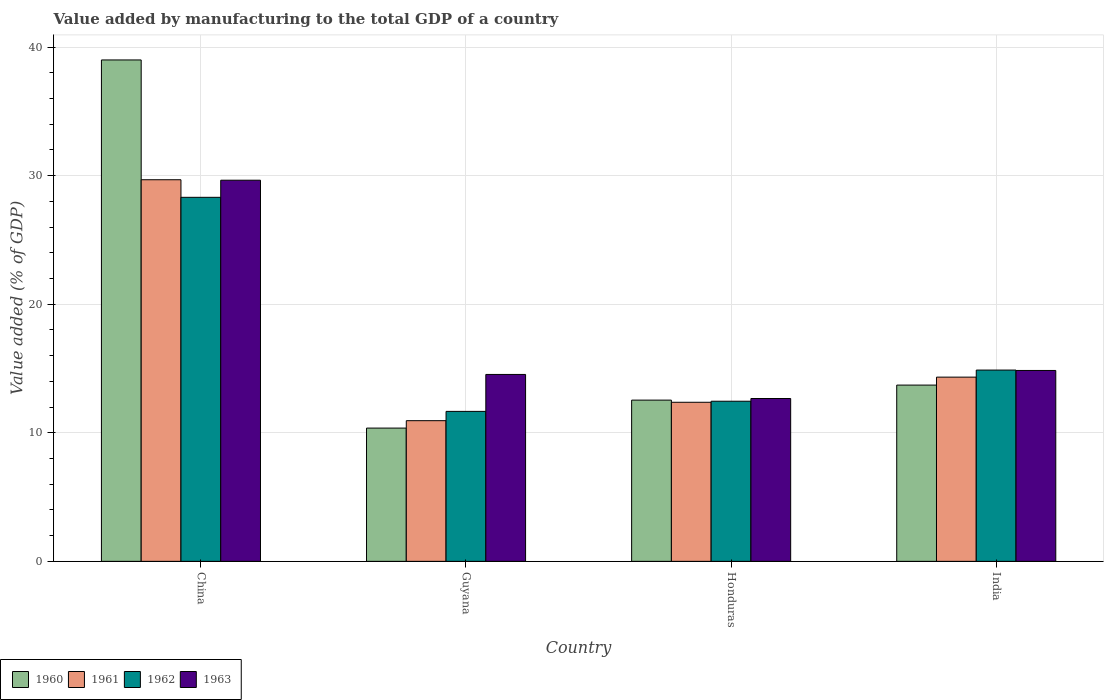How many different coloured bars are there?
Your response must be concise. 4. How many groups of bars are there?
Offer a very short reply. 4. Are the number of bars on each tick of the X-axis equal?
Your answer should be compact. Yes. How many bars are there on the 2nd tick from the left?
Provide a succinct answer. 4. What is the label of the 2nd group of bars from the left?
Your response must be concise. Guyana. What is the value added by manufacturing to the total GDP in 1962 in China?
Provide a succinct answer. 28.31. Across all countries, what is the maximum value added by manufacturing to the total GDP in 1961?
Provide a succinct answer. 29.68. Across all countries, what is the minimum value added by manufacturing to the total GDP in 1961?
Your response must be concise. 10.94. In which country was the value added by manufacturing to the total GDP in 1963 minimum?
Provide a short and direct response. Honduras. What is the total value added by manufacturing to the total GDP in 1963 in the graph?
Keep it short and to the point. 71.69. What is the difference between the value added by manufacturing to the total GDP in 1960 in Guyana and that in India?
Your response must be concise. -3.34. What is the difference between the value added by manufacturing to the total GDP in 1961 in Guyana and the value added by manufacturing to the total GDP in 1960 in India?
Give a very brief answer. -2.77. What is the average value added by manufacturing to the total GDP in 1960 per country?
Your response must be concise. 18.9. What is the difference between the value added by manufacturing to the total GDP of/in 1962 and value added by manufacturing to the total GDP of/in 1961 in China?
Offer a terse response. -1.37. In how many countries, is the value added by manufacturing to the total GDP in 1961 greater than 14 %?
Your answer should be very brief. 2. What is the ratio of the value added by manufacturing to the total GDP in 1961 in Guyana to that in Honduras?
Make the answer very short. 0.88. Is the difference between the value added by manufacturing to the total GDP in 1962 in China and India greater than the difference between the value added by manufacturing to the total GDP in 1961 in China and India?
Keep it short and to the point. No. What is the difference between the highest and the second highest value added by manufacturing to the total GDP in 1961?
Give a very brief answer. -17.31. What is the difference between the highest and the lowest value added by manufacturing to the total GDP in 1961?
Offer a very short reply. 18.74. In how many countries, is the value added by manufacturing to the total GDP in 1961 greater than the average value added by manufacturing to the total GDP in 1961 taken over all countries?
Offer a very short reply. 1. Is the sum of the value added by manufacturing to the total GDP in 1962 in China and Guyana greater than the maximum value added by manufacturing to the total GDP in 1961 across all countries?
Offer a very short reply. Yes. Is it the case that in every country, the sum of the value added by manufacturing to the total GDP in 1962 and value added by manufacturing to the total GDP in 1960 is greater than the sum of value added by manufacturing to the total GDP in 1963 and value added by manufacturing to the total GDP in 1961?
Provide a succinct answer. No. What does the 4th bar from the left in Guyana represents?
Make the answer very short. 1963. What does the 4th bar from the right in Honduras represents?
Make the answer very short. 1960. How many bars are there?
Give a very brief answer. 16. Are all the bars in the graph horizontal?
Your answer should be compact. No. Are the values on the major ticks of Y-axis written in scientific E-notation?
Your answer should be very brief. No. Does the graph contain any zero values?
Offer a very short reply. No. Does the graph contain grids?
Provide a succinct answer. Yes. Where does the legend appear in the graph?
Your answer should be compact. Bottom left. How are the legend labels stacked?
Ensure brevity in your answer.  Horizontal. What is the title of the graph?
Your answer should be compact. Value added by manufacturing to the total GDP of a country. What is the label or title of the X-axis?
Your response must be concise. Country. What is the label or title of the Y-axis?
Offer a very short reply. Value added (% of GDP). What is the Value added (% of GDP) in 1960 in China?
Your answer should be very brief. 39. What is the Value added (% of GDP) in 1961 in China?
Provide a short and direct response. 29.68. What is the Value added (% of GDP) of 1962 in China?
Give a very brief answer. 28.31. What is the Value added (% of GDP) of 1963 in China?
Keep it short and to the point. 29.64. What is the Value added (% of GDP) in 1960 in Guyana?
Keep it short and to the point. 10.37. What is the Value added (% of GDP) in 1961 in Guyana?
Give a very brief answer. 10.94. What is the Value added (% of GDP) in 1962 in Guyana?
Your answer should be very brief. 11.66. What is the Value added (% of GDP) of 1963 in Guyana?
Keep it short and to the point. 14.54. What is the Value added (% of GDP) in 1960 in Honduras?
Keep it short and to the point. 12.54. What is the Value added (% of GDP) in 1961 in Honduras?
Your answer should be very brief. 12.37. What is the Value added (% of GDP) of 1962 in Honduras?
Your answer should be very brief. 12.45. What is the Value added (% of GDP) of 1963 in Honduras?
Your answer should be compact. 12.67. What is the Value added (% of GDP) of 1960 in India?
Your response must be concise. 13.71. What is the Value added (% of GDP) in 1961 in India?
Give a very brief answer. 14.33. What is the Value added (% of GDP) of 1962 in India?
Provide a succinct answer. 14.88. What is the Value added (% of GDP) in 1963 in India?
Make the answer very short. 14.85. Across all countries, what is the maximum Value added (% of GDP) of 1960?
Provide a short and direct response. 39. Across all countries, what is the maximum Value added (% of GDP) in 1961?
Offer a terse response. 29.68. Across all countries, what is the maximum Value added (% of GDP) in 1962?
Your answer should be very brief. 28.31. Across all countries, what is the maximum Value added (% of GDP) in 1963?
Offer a very short reply. 29.64. Across all countries, what is the minimum Value added (% of GDP) in 1960?
Provide a short and direct response. 10.37. Across all countries, what is the minimum Value added (% of GDP) of 1961?
Provide a short and direct response. 10.94. Across all countries, what is the minimum Value added (% of GDP) of 1962?
Provide a short and direct response. 11.66. Across all countries, what is the minimum Value added (% of GDP) in 1963?
Offer a terse response. 12.67. What is the total Value added (% of GDP) of 1960 in the graph?
Offer a very short reply. 75.61. What is the total Value added (% of GDP) of 1961 in the graph?
Keep it short and to the point. 67.32. What is the total Value added (% of GDP) of 1962 in the graph?
Keep it short and to the point. 67.31. What is the total Value added (% of GDP) in 1963 in the graph?
Make the answer very short. 71.69. What is the difference between the Value added (% of GDP) of 1960 in China and that in Guyana?
Keep it short and to the point. 28.63. What is the difference between the Value added (% of GDP) of 1961 in China and that in Guyana?
Give a very brief answer. 18.74. What is the difference between the Value added (% of GDP) in 1962 in China and that in Guyana?
Ensure brevity in your answer.  16.65. What is the difference between the Value added (% of GDP) of 1963 in China and that in Guyana?
Your answer should be compact. 15.11. What is the difference between the Value added (% of GDP) in 1960 in China and that in Honduras?
Offer a terse response. 26.46. What is the difference between the Value added (% of GDP) in 1961 in China and that in Honduras?
Offer a very short reply. 17.31. What is the difference between the Value added (% of GDP) in 1962 in China and that in Honduras?
Your answer should be very brief. 15.86. What is the difference between the Value added (% of GDP) in 1963 in China and that in Honduras?
Offer a very short reply. 16.98. What is the difference between the Value added (% of GDP) in 1960 in China and that in India?
Offer a very short reply. 25.29. What is the difference between the Value added (% of GDP) of 1961 in China and that in India?
Keep it short and to the point. 15.35. What is the difference between the Value added (% of GDP) in 1962 in China and that in India?
Ensure brevity in your answer.  13.43. What is the difference between the Value added (% of GDP) in 1963 in China and that in India?
Provide a short and direct response. 14.8. What is the difference between the Value added (% of GDP) in 1960 in Guyana and that in Honduras?
Give a very brief answer. -2.18. What is the difference between the Value added (% of GDP) of 1961 in Guyana and that in Honduras?
Keep it short and to the point. -1.43. What is the difference between the Value added (% of GDP) of 1962 in Guyana and that in Honduras?
Provide a succinct answer. -0.79. What is the difference between the Value added (% of GDP) in 1963 in Guyana and that in Honduras?
Provide a short and direct response. 1.87. What is the difference between the Value added (% of GDP) of 1960 in Guyana and that in India?
Make the answer very short. -3.34. What is the difference between the Value added (% of GDP) in 1961 in Guyana and that in India?
Offer a terse response. -3.39. What is the difference between the Value added (% of GDP) of 1962 in Guyana and that in India?
Give a very brief answer. -3.21. What is the difference between the Value added (% of GDP) in 1963 in Guyana and that in India?
Your answer should be very brief. -0.31. What is the difference between the Value added (% of GDP) in 1960 in Honduras and that in India?
Provide a succinct answer. -1.17. What is the difference between the Value added (% of GDP) of 1961 in Honduras and that in India?
Your answer should be very brief. -1.96. What is the difference between the Value added (% of GDP) in 1962 in Honduras and that in India?
Offer a terse response. -2.42. What is the difference between the Value added (% of GDP) of 1963 in Honduras and that in India?
Your answer should be compact. -2.18. What is the difference between the Value added (% of GDP) of 1960 in China and the Value added (% of GDP) of 1961 in Guyana?
Provide a succinct answer. 28.06. What is the difference between the Value added (% of GDP) in 1960 in China and the Value added (% of GDP) in 1962 in Guyana?
Offer a very short reply. 27.33. What is the difference between the Value added (% of GDP) of 1960 in China and the Value added (% of GDP) of 1963 in Guyana?
Ensure brevity in your answer.  24.46. What is the difference between the Value added (% of GDP) in 1961 in China and the Value added (% of GDP) in 1962 in Guyana?
Offer a very short reply. 18.02. What is the difference between the Value added (% of GDP) in 1961 in China and the Value added (% of GDP) in 1963 in Guyana?
Offer a terse response. 15.14. What is the difference between the Value added (% of GDP) of 1962 in China and the Value added (% of GDP) of 1963 in Guyana?
Your response must be concise. 13.78. What is the difference between the Value added (% of GDP) of 1960 in China and the Value added (% of GDP) of 1961 in Honduras?
Ensure brevity in your answer.  26.63. What is the difference between the Value added (% of GDP) of 1960 in China and the Value added (% of GDP) of 1962 in Honduras?
Keep it short and to the point. 26.54. What is the difference between the Value added (% of GDP) in 1960 in China and the Value added (% of GDP) in 1963 in Honduras?
Your answer should be very brief. 26.33. What is the difference between the Value added (% of GDP) in 1961 in China and the Value added (% of GDP) in 1962 in Honduras?
Ensure brevity in your answer.  17.23. What is the difference between the Value added (% of GDP) in 1961 in China and the Value added (% of GDP) in 1963 in Honduras?
Provide a short and direct response. 17.01. What is the difference between the Value added (% of GDP) in 1962 in China and the Value added (% of GDP) in 1963 in Honduras?
Give a very brief answer. 15.65. What is the difference between the Value added (% of GDP) of 1960 in China and the Value added (% of GDP) of 1961 in India?
Provide a short and direct response. 24.67. What is the difference between the Value added (% of GDP) of 1960 in China and the Value added (% of GDP) of 1962 in India?
Offer a very short reply. 24.12. What is the difference between the Value added (% of GDP) in 1960 in China and the Value added (% of GDP) in 1963 in India?
Your response must be concise. 24.15. What is the difference between the Value added (% of GDP) of 1961 in China and the Value added (% of GDP) of 1962 in India?
Make the answer very short. 14.8. What is the difference between the Value added (% of GDP) of 1961 in China and the Value added (% of GDP) of 1963 in India?
Provide a succinct answer. 14.83. What is the difference between the Value added (% of GDP) of 1962 in China and the Value added (% of GDP) of 1963 in India?
Give a very brief answer. 13.47. What is the difference between the Value added (% of GDP) of 1960 in Guyana and the Value added (% of GDP) of 1961 in Honduras?
Offer a terse response. -2.01. What is the difference between the Value added (% of GDP) in 1960 in Guyana and the Value added (% of GDP) in 1962 in Honduras?
Provide a succinct answer. -2.09. What is the difference between the Value added (% of GDP) of 1960 in Guyana and the Value added (% of GDP) of 1963 in Honduras?
Offer a terse response. -2.3. What is the difference between the Value added (% of GDP) of 1961 in Guyana and the Value added (% of GDP) of 1962 in Honduras?
Keep it short and to the point. -1.51. What is the difference between the Value added (% of GDP) of 1961 in Guyana and the Value added (% of GDP) of 1963 in Honduras?
Your answer should be very brief. -1.73. What is the difference between the Value added (% of GDP) in 1962 in Guyana and the Value added (% of GDP) in 1963 in Honduras?
Make the answer very short. -1. What is the difference between the Value added (% of GDP) in 1960 in Guyana and the Value added (% of GDP) in 1961 in India?
Ensure brevity in your answer.  -3.96. What is the difference between the Value added (% of GDP) in 1960 in Guyana and the Value added (% of GDP) in 1962 in India?
Give a very brief answer. -4.51. What is the difference between the Value added (% of GDP) in 1960 in Guyana and the Value added (% of GDP) in 1963 in India?
Give a very brief answer. -4.48. What is the difference between the Value added (% of GDP) in 1961 in Guyana and the Value added (% of GDP) in 1962 in India?
Make the answer very short. -3.94. What is the difference between the Value added (% of GDP) of 1961 in Guyana and the Value added (% of GDP) of 1963 in India?
Offer a terse response. -3.91. What is the difference between the Value added (% of GDP) in 1962 in Guyana and the Value added (% of GDP) in 1963 in India?
Make the answer very short. -3.18. What is the difference between the Value added (% of GDP) of 1960 in Honduras and the Value added (% of GDP) of 1961 in India?
Your answer should be compact. -1.79. What is the difference between the Value added (% of GDP) of 1960 in Honduras and the Value added (% of GDP) of 1962 in India?
Your answer should be compact. -2.34. What is the difference between the Value added (% of GDP) of 1960 in Honduras and the Value added (% of GDP) of 1963 in India?
Ensure brevity in your answer.  -2.31. What is the difference between the Value added (% of GDP) of 1961 in Honduras and the Value added (% of GDP) of 1962 in India?
Ensure brevity in your answer.  -2.51. What is the difference between the Value added (% of GDP) of 1961 in Honduras and the Value added (% of GDP) of 1963 in India?
Provide a succinct answer. -2.47. What is the difference between the Value added (% of GDP) of 1962 in Honduras and the Value added (% of GDP) of 1963 in India?
Ensure brevity in your answer.  -2.39. What is the average Value added (% of GDP) of 1960 per country?
Your answer should be compact. 18.9. What is the average Value added (% of GDP) of 1961 per country?
Your answer should be compact. 16.83. What is the average Value added (% of GDP) of 1962 per country?
Keep it short and to the point. 16.83. What is the average Value added (% of GDP) of 1963 per country?
Make the answer very short. 17.92. What is the difference between the Value added (% of GDP) in 1960 and Value added (% of GDP) in 1961 in China?
Your response must be concise. 9.32. What is the difference between the Value added (% of GDP) in 1960 and Value added (% of GDP) in 1962 in China?
Provide a succinct answer. 10.69. What is the difference between the Value added (% of GDP) of 1960 and Value added (% of GDP) of 1963 in China?
Give a very brief answer. 9.35. What is the difference between the Value added (% of GDP) of 1961 and Value added (% of GDP) of 1962 in China?
Your response must be concise. 1.37. What is the difference between the Value added (% of GDP) in 1961 and Value added (% of GDP) in 1963 in China?
Your response must be concise. 0.04. What is the difference between the Value added (% of GDP) of 1962 and Value added (% of GDP) of 1963 in China?
Your answer should be very brief. -1.33. What is the difference between the Value added (% of GDP) of 1960 and Value added (% of GDP) of 1961 in Guyana?
Your answer should be compact. -0.58. What is the difference between the Value added (% of GDP) of 1960 and Value added (% of GDP) of 1962 in Guyana?
Your answer should be compact. -1.3. What is the difference between the Value added (% of GDP) of 1960 and Value added (% of GDP) of 1963 in Guyana?
Provide a short and direct response. -4.17. What is the difference between the Value added (% of GDP) of 1961 and Value added (% of GDP) of 1962 in Guyana?
Give a very brief answer. -0.72. What is the difference between the Value added (% of GDP) of 1961 and Value added (% of GDP) of 1963 in Guyana?
Your response must be concise. -3.6. What is the difference between the Value added (% of GDP) in 1962 and Value added (% of GDP) in 1963 in Guyana?
Make the answer very short. -2.87. What is the difference between the Value added (% of GDP) in 1960 and Value added (% of GDP) in 1961 in Honduras?
Keep it short and to the point. 0.17. What is the difference between the Value added (% of GDP) in 1960 and Value added (% of GDP) in 1962 in Honduras?
Ensure brevity in your answer.  0.09. What is the difference between the Value added (% of GDP) in 1960 and Value added (% of GDP) in 1963 in Honduras?
Offer a very short reply. -0.13. What is the difference between the Value added (% of GDP) in 1961 and Value added (% of GDP) in 1962 in Honduras?
Offer a very short reply. -0.08. What is the difference between the Value added (% of GDP) in 1961 and Value added (% of GDP) in 1963 in Honduras?
Give a very brief answer. -0.29. What is the difference between the Value added (% of GDP) of 1962 and Value added (% of GDP) of 1963 in Honduras?
Provide a short and direct response. -0.21. What is the difference between the Value added (% of GDP) of 1960 and Value added (% of GDP) of 1961 in India?
Your response must be concise. -0.62. What is the difference between the Value added (% of GDP) in 1960 and Value added (% of GDP) in 1962 in India?
Ensure brevity in your answer.  -1.17. What is the difference between the Value added (% of GDP) in 1960 and Value added (% of GDP) in 1963 in India?
Give a very brief answer. -1.14. What is the difference between the Value added (% of GDP) of 1961 and Value added (% of GDP) of 1962 in India?
Offer a very short reply. -0.55. What is the difference between the Value added (% of GDP) in 1961 and Value added (% of GDP) in 1963 in India?
Your response must be concise. -0.52. What is the difference between the Value added (% of GDP) in 1962 and Value added (% of GDP) in 1963 in India?
Provide a short and direct response. 0.03. What is the ratio of the Value added (% of GDP) in 1960 in China to that in Guyana?
Ensure brevity in your answer.  3.76. What is the ratio of the Value added (% of GDP) of 1961 in China to that in Guyana?
Offer a terse response. 2.71. What is the ratio of the Value added (% of GDP) in 1962 in China to that in Guyana?
Provide a succinct answer. 2.43. What is the ratio of the Value added (% of GDP) in 1963 in China to that in Guyana?
Offer a terse response. 2.04. What is the ratio of the Value added (% of GDP) of 1960 in China to that in Honduras?
Offer a very short reply. 3.11. What is the ratio of the Value added (% of GDP) in 1961 in China to that in Honduras?
Ensure brevity in your answer.  2.4. What is the ratio of the Value added (% of GDP) in 1962 in China to that in Honduras?
Your answer should be very brief. 2.27. What is the ratio of the Value added (% of GDP) in 1963 in China to that in Honduras?
Your answer should be compact. 2.34. What is the ratio of the Value added (% of GDP) of 1960 in China to that in India?
Make the answer very short. 2.84. What is the ratio of the Value added (% of GDP) of 1961 in China to that in India?
Offer a very short reply. 2.07. What is the ratio of the Value added (% of GDP) of 1962 in China to that in India?
Offer a very short reply. 1.9. What is the ratio of the Value added (% of GDP) of 1963 in China to that in India?
Your response must be concise. 2. What is the ratio of the Value added (% of GDP) in 1960 in Guyana to that in Honduras?
Give a very brief answer. 0.83. What is the ratio of the Value added (% of GDP) in 1961 in Guyana to that in Honduras?
Offer a terse response. 0.88. What is the ratio of the Value added (% of GDP) in 1962 in Guyana to that in Honduras?
Your response must be concise. 0.94. What is the ratio of the Value added (% of GDP) in 1963 in Guyana to that in Honduras?
Provide a short and direct response. 1.15. What is the ratio of the Value added (% of GDP) in 1960 in Guyana to that in India?
Ensure brevity in your answer.  0.76. What is the ratio of the Value added (% of GDP) in 1961 in Guyana to that in India?
Ensure brevity in your answer.  0.76. What is the ratio of the Value added (% of GDP) of 1962 in Guyana to that in India?
Your answer should be compact. 0.78. What is the ratio of the Value added (% of GDP) in 1963 in Guyana to that in India?
Provide a succinct answer. 0.98. What is the ratio of the Value added (% of GDP) in 1960 in Honduras to that in India?
Offer a terse response. 0.91. What is the ratio of the Value added (% of GDP) in 1961 in Honduras to that in India?
Provide a succinct answer. 0.86. What is the ratio of the Value added (% of GDP) in 1962 in Honduras to that in India?
Your answer should be compact. 0.84. What is the ratio of the Value added (% of GDP) of 1963 in Honduras to that in India?
Your answer should be very brief. 0.85. What is the difference between the highest and the second highest Value added (% of GDP) in 1960?
Ensure brevity in your answer.  25.29. What is the difference between the highest and the second highest Value added (% of GDP) in 1961?
Offer a very short reply. 15.35. What is the difference between the highest and the second highest Value added (% of GDP) in 1962?
Your answer should be very brief. 13.43. What is the difference between the highest and the second highest Value added (% of GDP) in 1963?
Keep it short and to the point. 14.8. What is the difference between the highest and the lowest Value added (% of GDP) of 1960?
Your answer should be compact. 28.63. What is the difference between the highest and the lowest Value added (% of GDP) of 1961?
Your answer should be very brief. 18.74. What is the difference between the highest and the lowest Value added (% of GDP) of 1962?
Offer a very short reply. 16.65. What is the difference between the highest and the lowest Value added (% of GDP) in 1963?
Offer a very short reply. 16.98. 